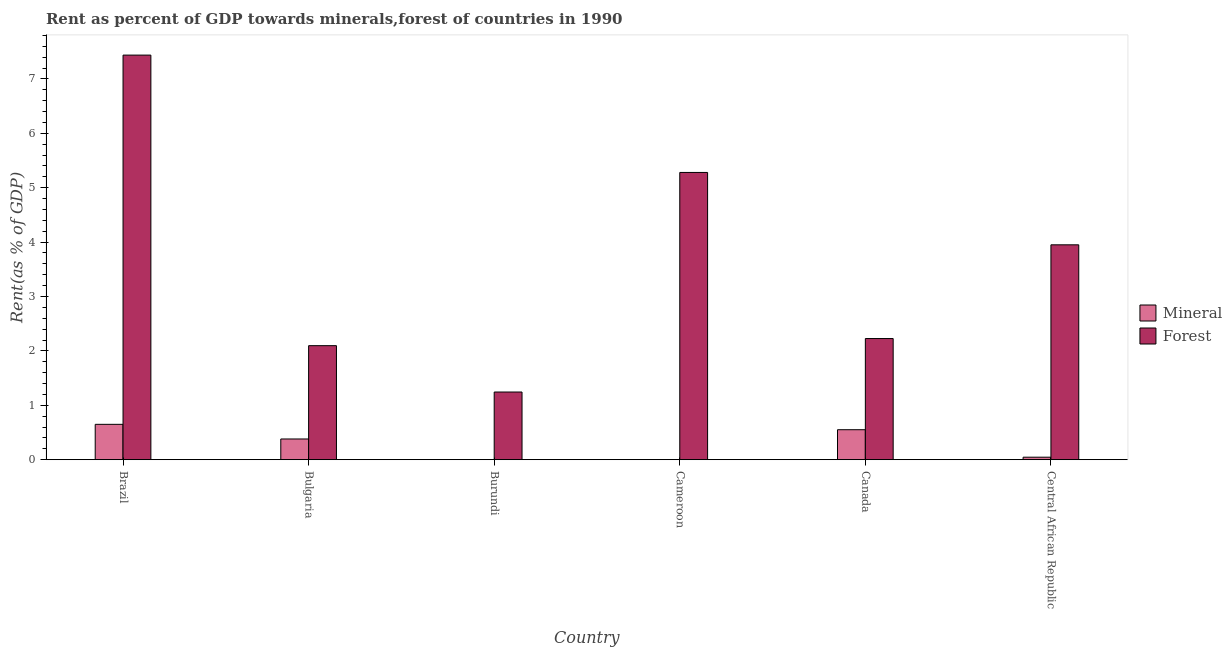Are the number of bars per tick equal to the number of legend labels?
Keep it short and to the point. Yes. Are the number of bars on each tick of the X-axis equal?
Give a very brief answer. Yes. How many bars are there on the 3rd tick from the right?
Provide a succinct answer. 2. What is the label of the 4th group of bars from the left?
Provide a short and direct response. Cameroon. In how many cases, is the number of bars for a given country not equal to the number of legend labels?
Your answer should be compact. 0. What is the mineral rent in Central African Republic?
Offer a terse response. 0.05. Across all countries, what is the maximum forest rent?
Make the answer very short. 7.44. Across all countries, what is the minimum forest rent?
Offer a terse response. 1.24. In which country was the mineral rent maximum?
Provide a short and direct response. Brazil. In which country was the forest rent minimum?
Your response must be concise. Burundi. What is the total mineral rent in the graph?
Make the answer very short. 1.63. What is the difference between the forest rent in Brazil and that in Central African Republic?
Offer a terse response. 3.49. What is the difference between the forest rent in Bulgaria and the mineral rent in Canada?
Give a very brief answer. 1.55. What is the average forest rent per country?
Offer a very short reply. 3.71. What is the difference between the mineral rent and forest rent in Bulgaria?
Your answer should be compact. -1.72. In how many countries, is the forest rent greater than 3.6 %?
Make the answer very short. 3. What is the ratio of the mineral rent in Brazil to that in Bulgaria?
Your response must be concise. 1.71. Is the mineral rent in Bulgaria less than that in Cameroon?
Make the answer very short. No. Is the difference between the forest rent in Burundi and Central African Republic greater than the difference between the mineral rent in Burundi and Central African Republic?
Make the answer very short. No. What is the difference between the highest and the second highest mineral rent?
Provide a short and direct response. 0.1. What is the difference between the highest and the lowest forest rent?
Ensure brevity in your answer.  6.19. What does the 1st bar from the left in Cameroon represents?
Provide a succinct answer. Mineral. What does the 2nd bar from the right in Cameroon represents?
Your answer should be very brief. Mineral. How many bars are there?
Give a very brief answer. 12. What is the difference between two consecutive major ticks on the Y-axis?
Make the answer very short. 1. Does the graph contain any zero values?
Ensure brevity in your answer.  No. What is the title of the graph?
Make the answer very short. Rent as percent of GDP towards minerals,forest of countries in 1990. Does "Chemicals" appear as one of the legend labels in the graph?
Ensure brevity in your answer.  No. What is the label or title of the X-axis?
Keep it short and to the point. Country. What is the label or title of the Y-axis?
Ensure brevity in your answer.  Rent(as % of GDP). What is the Rent(as % of GDP) of Mineral in Brazil?
Give a very brief answer. 0.65. What is the Rent(as % of GDP) in Forest in Brazil?
Keep it short and to the point. 7.44. What is the Rent(as % of GDP) of Mineral in Bulgaria?
Give a very brief answer. 0.38. What is the Rent(as % of GDP) in Forest in Bulgaria?
Your response must be concise. 2.1. What is the Rent(as % of GDP) in Mineral in Burundi?
Offer a very short reply. 0. What is the Rent(as % of GDP) in Forest in Burundi?
Give a very brief answer. 1.24. What is the Rent(as % of GDP) in Mineral in Cameroon?
Give a very brief answer. 0. What is the Rent(as % of GDP) of Forest in Cameroon?
Offer a very short reply. 5.28. What is the Rent(as % of GDP) in Mineral in Canada?
Keep it short and to the point. 0.55. What is the Rent(as % of GDP) of Forest in Canada?
Provide a succinct answer. 2.23. What is the Rent(as % of GDP) of Mineral in Central African Republic?
Give a very brief answer. 0.05. What is the Rent(as % of GDP) of Forest in Central African Republic?
Your answer should be very brief. 3.95. Across all countries, what is the maximum Rent(as % of GDP) in Mineral?
Provide a short and direct response. 0.65. Across all countries, what is the maximum Rent(as % of GDP) of Forest?
Keep it short and to the point. 7.44. Across all countries, what is the minimum Rent(as % of GDP) of Mineral?
Ensure brevity in your answer.  0. Across all countries, what is the minimum Rent(as % of GDP) of Forest?
Your answer should be very brief. 1.24. What is the total Rent(as % of GDP) in Mineral in the graph?
Offer a terse response. 1.63. What is the total Rent(as % of GDP) of Forest in the graph?
Your response must be concise. 22.24. What is the difference between the Rent(as % of GDP) in Mineral in Brazil and that in Bulgaria?
Provide a succinct answer. 0.27. What is the difference between the Rent(as % of GDP) of Forest in Brazil and that in Bulgaria?
Ensure brevity in your answer.  5.34. What is the difference between the Rent(as % of GDP) of Mineral in Brazil and that in Burundi?
Your answer should be very brief. 0.65. What is the difference between the Rent(as % of GDP) of Forest in Brazil and that in Burundi?
Keep it short and to the point. 6.19. What is the difference between the Rent(as % of GDP) of Mineral in Brazil and that in Cameroon?
Give a very brief answer. 0.65. What is the difference between the Rent(as % of GDP) in Forest in Brazil and that in Cameroon?
Ensure brevity in your answer.  2.16. What is the difference between the Rent(as % of GDP) of Mineral in Brazil and that in Canada?
Keep it short and to the point. 0.1. What is the difference between the Rent(as % of GDP) in Forest in Brazil and that in Canada?
Your response must be concise. 5.21. What is the difference between the Rent(as % of GDP) of Mineral in Brazil and that in Central African Republic?
Your answer should be compact. 0.6. What is the difference between the Rent(as % of GDP) of Forest in Brazil and that in Central African Republic?
Provide a short and direct response. 3.49. What is the difference between the Rent(as % of GDP) in Mineral in Bulgaria and that in Burundi?
Make the answer very short. 0.38. What is the difference between the Rent(as % of GDP) of Forest in Bulgaria and that in Burundi?
Provide a succinct answer. 0.85. What is the difference between the Rent(as % of GDP) of Mineral in Bulgaria and that in Cameroon?
Ensure brevity in your answer.  0.38. What is the difference between the Rent(as % of GDP) in Forest in Bulgaria and that in Cameroon?
Provide a succinct answer. -3.18. What is the difference between the Rent(as % of GDP) of Mineral in Bulgaria and that in Canada?
Provide a succinct answer. -0.17. What is the difference between the Rent(as % of GDP) in Forest in Bulgaria and that in Canada?
Offer a very short reply. -0.13. What is the difference between the Rent(as % of GDP) of Mineral in Bulgaria and that in Central African Republic?
Your answer should be compact. 0.34. What is the difference between the Rent(as % of GDP) of Forest in Bulgaria and that in Central African Republic?
Give a very brief answer. -1.85. What is the difference between the Rent(as % of GDP) of Mineral in Burundi and that in Cameroon?
Provide a short and direct response. 0. What is the difference between the Rent(as % of GDP) of Forest in Burundi and that in Cameroon?
Offer a very short reply. -4.04. What is the difference between the Rent(as % of GDP) of Mineral in Burundi and that in Canada?
Your response must be concise. -0.55. What is the difference between the Rent(as % of GDP) in Forest in Burundi and that in Canada?
Give a very brief answer. -0.98. What is the difference between the Rent(as % of GDP) in Mineral in Burundi and that in Central African Republic?
Your response must be concise. -0.04. What is the difference between the Rent(as % of GDP) of Forest in Burundi and that in Central African Republic?
Keep it short and to the point. -2.71. What is the difference between the Rent(as % of GDP) of Mineral in Cameroon and that in Canada?
Offer a terse response. -0.55. What is the difference between the Rent(as % of GDP) in Forest in Cameroon and that in Canada?
Give a very brief answer. 3.05. What is the difference between the Rent(as % of GDP) of Mineral in Cameroon and that in Central African Republic?
Your response must be concise. -0.05. What is the difference between the Rent(as % of GDP) in Forest in Cameroon and that in Central African Republic?
Your response must be concise. 1.33. What is the difference between the Rent(as % of GDP) of Mineral in Canada and that in Central African Republic?
Your answer should be compact. 0.51. What is the difference between the Rent(as % of GDP) of Forest in Canada and that in Central African Republic?
Offer a very short reply. -1.72. What is the difference between the Rent(as % of GDP) of Mineral in Brazil and the Rent(as % of GDP) of Forest in Bulgaria?
Your answer should be compact. -1.45. What is the difference between the Rent(as % of GDP) in Mineral in Brazil and the Rent(as % of GDP) in Forest in Burundi?
Make the answer very short. -0.59. What is the difference between the Rent(as % of GDP) in Mineral in Brazil and the Rent(as % of GDP) in Forest in Cameroon?
Give a very brief answer. -4.63. What is the difference between the Rent(as % of GDP) of Mineral in Brazil and the Rent(as % of GDP) of Forest in Canada?
Offer a very short reply. -1.58. What is the difference between the Rent(as % of GDP) in Mineral in Bulgaria and the Rent(as % of GDP) in Forest in Burundi?
Your answer should be very brief. -0.86. What is the difference between the Rent(as % of GDP) of Mineral in Bulgaria and the Rent(as % of GDP) of Forest in Cameroon?
Keep it short and to the point. -4.9. What is the difference between the Rent(as % of GDP) of Mineral in Bulgaria and the Rent(as % of GDP) of Forest in Canada?
Provide a short and direct response. -1.85. What is the difference between the Rent(as % of GDP) in Mineral in Bulgaria and the Rent(as % of GDP) in Forest in Central African Republic?
Your answer should be very brief. -3.57. What is the difference between the Rent(as % of GDP) in Mineral in Burundi and the Rent(as % of GDP) in Forest in Cameroon?
Ensure brevity in your answer.  -5.28. What is the difference between the Rent(as % of GDP) in Mineral in Burundi and the Rent(as % of GDP) in Forest in Canada?
Provide a short and direct response. -2.23. What is the difference between the Rent(as % of GDP) of Mineral in Burundi and the Rent(as % of GDP) of Forest in Central African Republic?
Provide a short and direct response. -3.95. What is the difference between the Rent(as % of GDP) in Mineral in Cameroon and the Rent(as % of GDP) in Forest in Canada?
Your answer should be compact. -2.23. What is the difference between the Rent(as % of GDP) in Mineral in Cameroon and the Rent(as % of GDP) in Forest in Central African Republic?
Provide a short and direct response. -3.95. What is the difference between the Rent(as % of GDP) in Mineral in Canada and the Rent(as % of GDP) in Forest in Central African Republic?
Provide a short and direct response. -3.4. What is the average Rent(as % of GDP) of Mineral per country?
Keep it short and to the point. 0.27. What is the average Rent(as % of GDP) of Forest per country?
Make the answer very short. 3.71. What is the difference between the Rent(as % of GDP) in Mineral and Rent(as % of GDP) in Forest in Brazil?
Provide a succinct answer. -6.79. What is the difference between the Rent(as % of GDP) of Mineral and Rent(as % of GDP) of Forest in Bulgaria?
Your response must be concise. -1.72. What is the difference between the Rent(as % of GDP) of Mineral and Rent(as % of GDP) of Forest in Burundi?
Give a very brief answer. -1.24. What is the difference between the Rent(as % of GDP) of Mineral and Rent(as % of GDP) of Forest in Cameroon?
Offer a terse response. -5.28. What is the difference between the Rent(as % of GDP) of Mineral and Rent(as % of GDP) of Forest in Canada?
Keep it short and to the point. -1.68. What is the difference between the Rent(as % of GDP) in Mineral and Rent(as % of GDP) in Forest in Central African Republic?
Your answer should be very brief. -3.9. What is the ratio of the Rent(as % of GDP) of Mineral in Brazil to that in Bulgaria?
Your response must be concise. 1.71. What is the ratio of the Rent(as % of GDP) in Forest in Brazil to that in Bulgaria?
Give a very brief answer. 3.55. What is the ratio of the Rent(as % of GDP) of Mineral in Brazil to that in Burundi?
Keep it short and to the point. 371.23. What is the ratio of the Rent(as % of GDP) in Forest in Brazil to that in Burundi?
Give a very brief answer. 5.98. What is the ratio of the Rent(as % of GDP) of Mineral in Brazil to that in Cameroon?
Your response must be concise. 4113.8. What is the ratio of the Rent(as % of GDP) of Forest in Brazil to that in Cameroon?
Offer a very short reply. 1.41. What is the ratio of the Rent(as % of GDP) of Mineral in Brazil to that in Canada?
Make the answer very short. 1.18. What is the ratio of the Rent(as % of GDP) in Forest in Brazil to that in Canada?
Your answer should be compact. 3.34. What is the ratio of the Rent(as % of GDP) of Mineral in Brazil to that in Central African Republic?
Offer a terse response. 14.17. What is the ratio of the Rent(as % of GDP) in Forest in Brazil to that in Central African Republic?
Ensure brevity in your answer.  1.88. What is the ratio of the Rent(as % of GDP) in Mineral in Bulgaria to that in Burundi?
Make the answer very short. 217.49. What is the ratio of the Rent(as % of GDP) in Forest in Bulgaria to that in Burundi?
Ensure brevity in your answer.  1.69. What is the ratio of the Rent(as % of GDP) in Mineral in Bulgaria to that in Cameroon?
Your answer should be compact. 2410.14. What is the ratio of the Rent(as % of GDP) of Forest in Bulgaria to that in Cameroon?
Your answer should be compact. 0.4. What is the ratio of the Rent(as % of GDP) of Mineral in Bulgaria to that in Canada?
Your answer should be very brief. 0.69. What is the ratio of the Rent(as % of GDP) of Mineral in Bulgaria to that in Central African Republic?
Your response must be concise. 8.3. What is the ratio of the Rent(as % of GDP) of Forest in Bulgaria to that in Central African Republic?
Your response must be concise. 0.53. What is the ratio of the Rent(as % of GDP) of Mineral in Burundi to that in Cameroon?
Offer a very short reply. 11.08. What is the ratio of the Rent(as % of GDP) of Forest in Burundi to that in Cameroon?
Give a very brief answer. 0.24. What is the ratio of the Rent(as % of GDP) of Mineral in Burundi to that in Canada?
Provide a succinct answer. 0. What is the ratio of the Rent(as % of GDP) in Forest in Burundi to that in Canada?
Ensure brevity in your answer.  0.56. What is the ratio of the Rent(as % of GDP) in Mineral in Burundi to that in Central African Republic?
Provide a short and direct response. 0.04. What is the ratio of the Rent(as % of GDP) of Forest in Burundi to that in Central African Republic?
Your answer should be compact. 0.31. What is the ratio of the Rent(as % of GDP) of Mineral in Cameroon to that in Canada?
Provide a succinct answer. 0. What is the ratio of the Rent(as % of GDP) in Forest in Cameroon to that in Canada?
Provide a succinct answer. 2.37. What is the ratio of the Rent(as % of GDP) in Mineral in Cameroon to that in Central African Republic?
Your response must be concise. 0. What is the ratio of the Rent(as % of GDP) in Forest in Cameroon to that in Central African Republic?
Your answer should be very brief. 1.34. What is the ratio of the Rent(as % of GDP) in Mineral in Canada to that in Central African Republic?
Your answer should be compact. 12.01. What is the ratio of the Rent(as % of GDP) in Forest in Canada to that in Central African Republic?
Keep it short and to the point. 0.56. What is the difference between the highest and the second highest Rent(as % of GDP) of Mineral?
Give a very brief answer. 0.1. What is the difference between the highest and the second highest Rent(as % of GDP) in Forest?
Offer a terse response. 2.16. What is the difference between the highest and the lowest Rent(as % of GDP) in Mineral?
Your response must be concise. 0.65. What is the difference between the highest and the lowest Rent(as % of GDP) in Forest?
Your response must be concise. 6.19. 